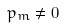Convert formula to latex. <formula><loc_0><loc_0><loc_500><loc_500>p _ { m } \neq 0</formula> 